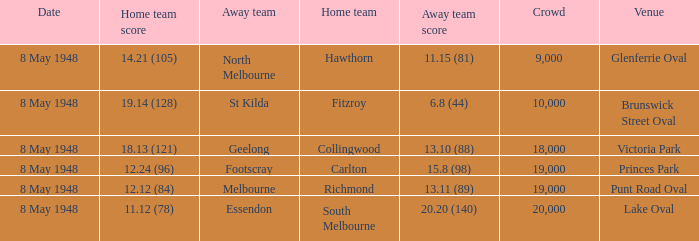Which home team has a score of 11.12 (78)? South Melbourne. 